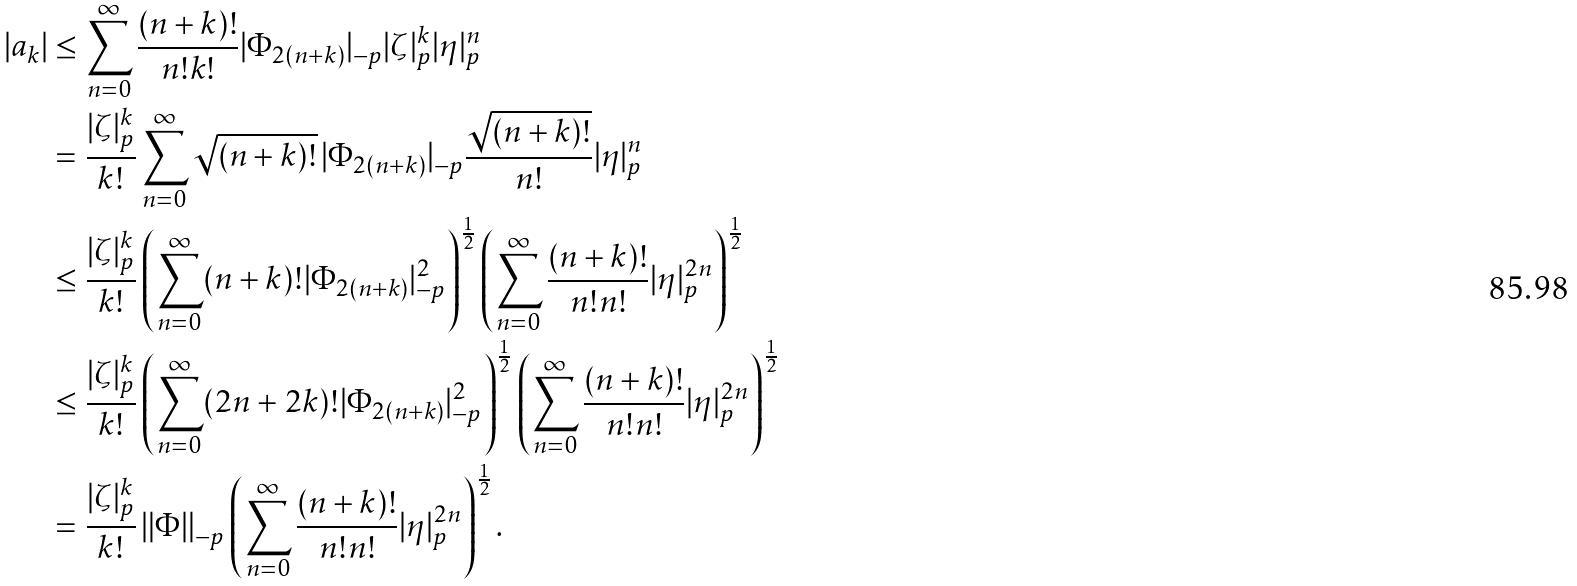Convert formula to latex. <formula><loc_0><loc_0><loc_500><loc_500>| a _ { k } | & \leq \sum _ { n = 0 } ^ { \infty } \frac { ( n + k ) ! } { n ! k ! } | \Phi _ { 2 ( n + k ) } | _ { - p } | \zeta | _ { p } ^ { k } | \eta | _ { p } ^ { n } \\ & = \frac { | \zeta | _ { p } ^ { k } } { k ! } \sum _ { n = 0 } ^ { \infty } \sqrt { ( n + k ) ! } \, | \Phi _ { 2 ( n + k ) } | _ { - p } \frac { \sqrt { ( n + k ) ! } } { n ! } | \eta | _ { p } ^ { n } \\ & \leq \frac { | \zeta | _ { p } ^ { k } } { k ! } \left ( \sum _ { n = 0 } ^ { \infty } ( n + k ) ! | \Phi _ { 2 ( n + k ) } | _ { - p } ^ { 2 } \right ) ^ { \frac { 1 } { 2 } } \left ( \sum _ { n = 0 } ^ { \infty } \frac { ( n + k ) ! } { n ! n ! } | \eta | _ { p } ^ { 2 n } \right ) ^ { \frac { 1 } { 2 } } \\ & \leq \frac { | \zeta | _ { p } ^ { k } } { k ! } \left ( \sum _ { n = 0 } ^ { \infty } ( 2 n + 2 k ) ! | \Phi _ { 2 ( n + k ) } | _ { - p } ^ { 2 } \right ) ^ { \frac { 1 } { 2 } } \left ( \sum _ { n = 0 } ^ { \infty } \frac { ( n + k ) ! } { n ! n ! } | \eta | _ { p } ^ { 2 n } \right ) ^ { \frac { 1 } { 2 } } \\ & = \frac { | \zeta | _ { p } ^ { k } } { k ! } \left \| \Phi \right \| _ { - p } \left ( \sum _ { n = 0 } ^ { \infty } \frac { ( n + k ) ! } { n ! n ! } | \eta | _ { p } ^ { 2 n } \right ) ^ { \frac { 1 } { 2 } } .</formula> 